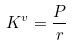<formula> <loc_0><loc_0><loc_500><loc_500>K ^ { v } = \frac { P } { r }</formula> 